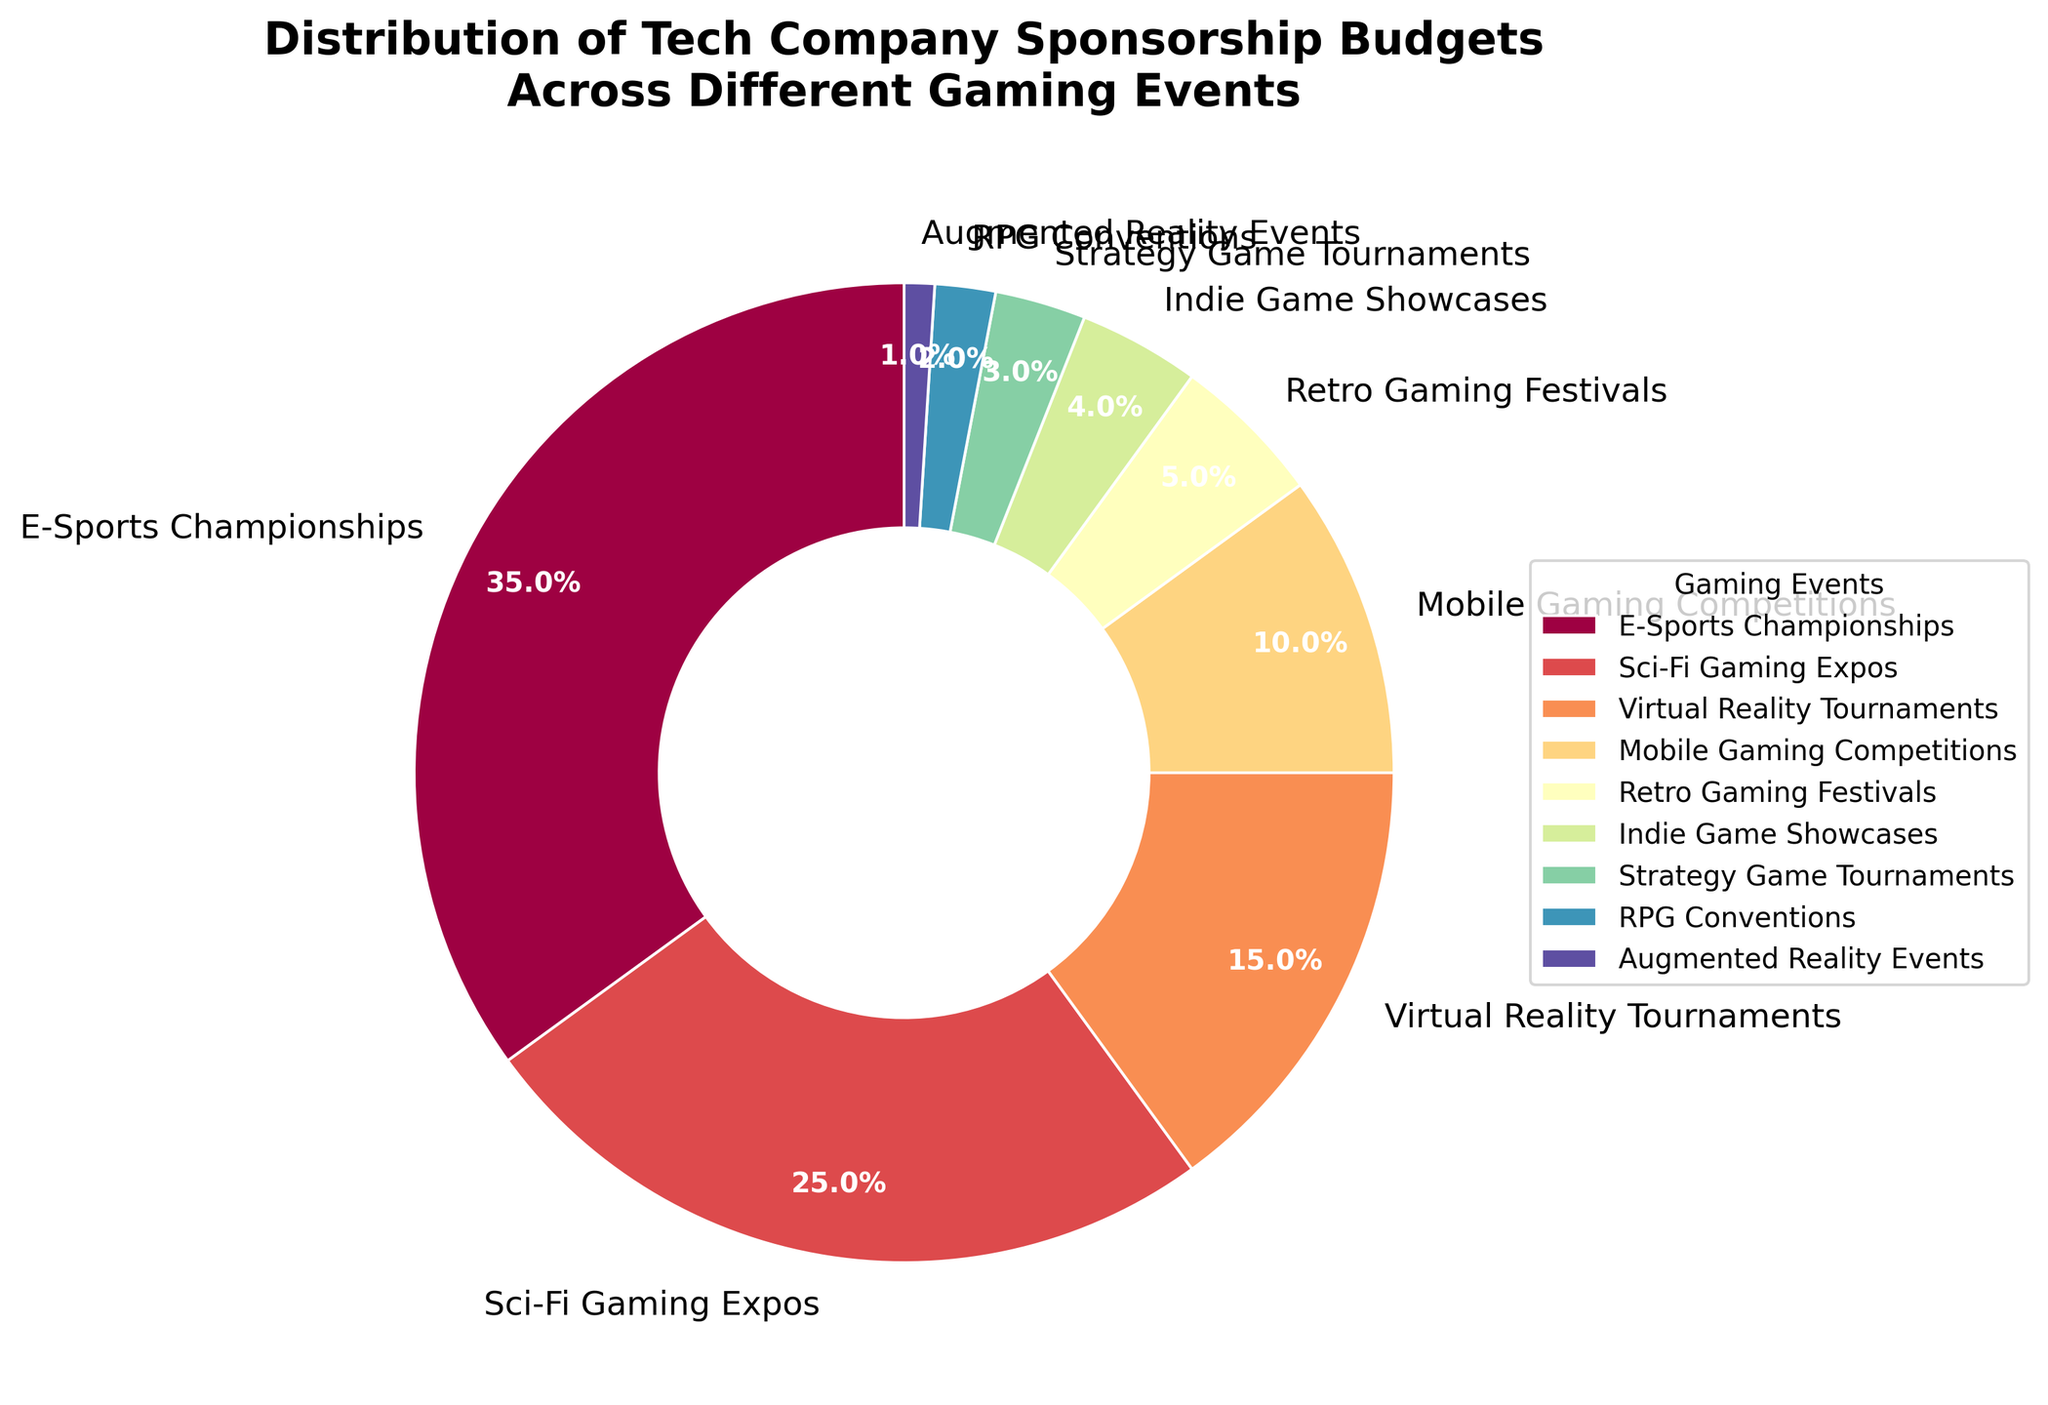Which event has the highest sponsorship percentage? The pie chart shows various events with their respective percentages. The event with the highest value (35%) is "E-Sports Championships."
Answer: E-Sports Championships Which event has the smallest percentage of the budget? Looking at the pie chart, the smallest slice represents "Augmented Reality Events" with a budget of 1%.
Answer: Augmented Reality Events What is the total budget percentage allocated to Sci-Fi Gaming Expos and RPG Conventions combined? From the chart, Sci-Fi Gaming Expos have 25% and RPG Conventions have 2%. Adding these values, 25 + 2 = 27%.
Answer: 27% How does the budget for Virtual Reality Tournaments compare to the budget for Mobile Gaming Competitions? The chart shows that Virtual Reality Tournaments have 15% and Mobile Gaming Competitions have 10%, indicating that Virtual Reality Tournaments have a higher budget.
Answer: Virtual Reality Tournaments have a higher budget How many events have a budget allocation less than 5%? Based on the pie chart, "Indie Game Showcases" (4%), "Strategy Game Tournaments" (3%), "RPG Conventions" (2%), and "Augmented Reality Events" (1%) fall below the 5% threshold.
Answer: 4 Which two events, when combined, make up 40% of the budget? According to the chart, "Virtual Reality Tournaments" (15%) and "Mobile Gaming Competitions" (10%) combined make 25%, so we need another event with 15%. Adding these, the "E-Sports Championships" (35%) with "Augmented Reality Events" (1%), and all others don't make 40% except "E-Sports Championships" (35%) and "Retro Gaming Festivals" (5%) will make 35+5=40%.
Answer: E-Sports Championships and Retro Gaming Festivals What is the average budget allocation across all events? The average allocation is calculated by summing up the percentages of all events and then dividing by the number of events. The sum of percentages is 100%, and there are 9 events, so the average is 100/9 ≈ 11.1%.
Answer: 11.1% What's the range of budget allocations across different events? The range is the difference between the highest and the lowest percentages in the chart. The highest is 35% (E-Sports Championships) and the lowest is 1% (Augmented Reality Events), so the range is 35 - 1 = 34%.
Answer: 34% Which event has a budget percentage closest to the median value of budget allocations? To find the median, sort the percentages: (1, 2, 3, 4, 5, 10, 15, 25, 35). The median in this sorted list (the 5th value) is 5%. The event with a budget closest to 5% is "Retro Gaming Festivals".
Answer: Retro Gaming Festivals 